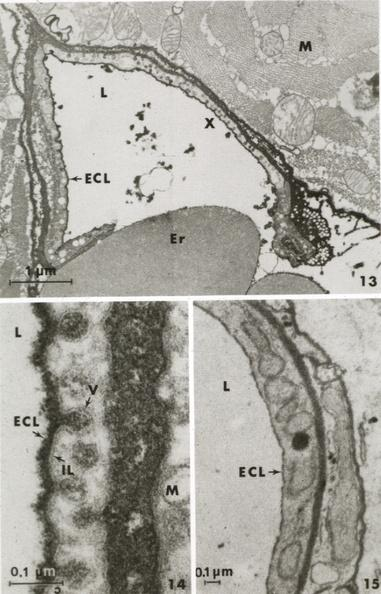does this image show muscle ruthenium red to illustrate glycocalyx?
Answer the question using a single word or phrase. Yes 